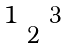<formula> <loc_0><loc_0><loc_500><loc_500>\begin{smallmatrix} & & & & \\ & & & & \\ & 1 & & 3 & \\ & & 2 & & \\ & & & & \\ & & & & \end{smallmatrix}</formula> 